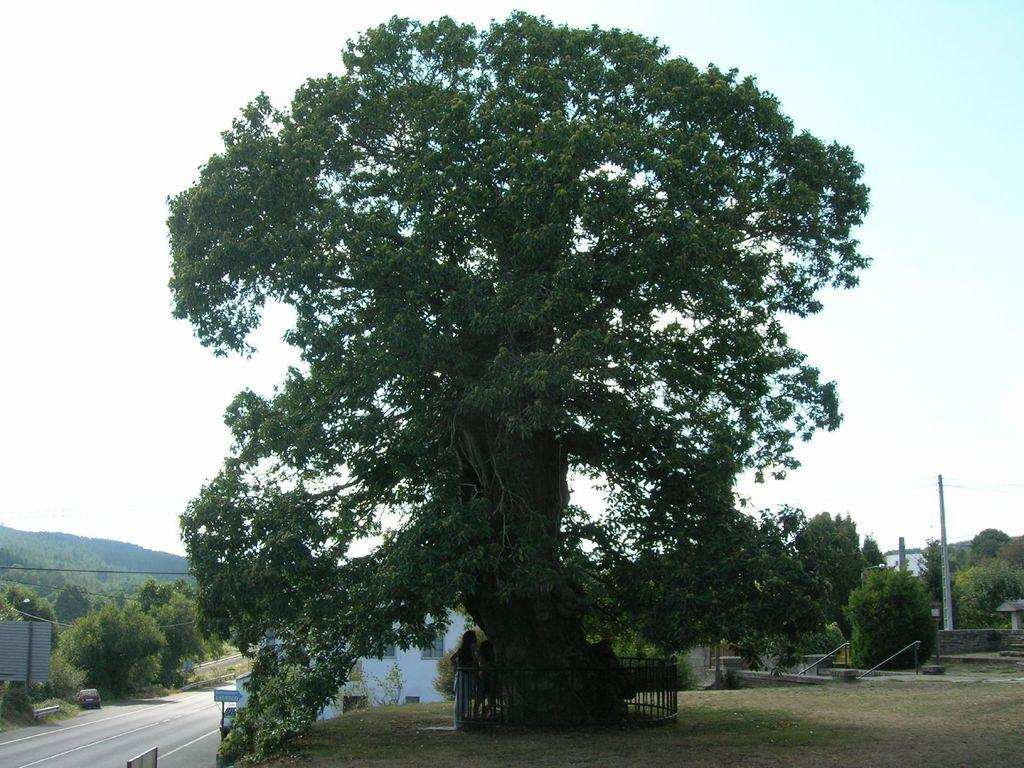What type of vegetation can be seen in the image? There are trees in the image. What color are the trees? The trees are green. What structures are visible in the background of the image? There are buildings in the background of the image. What color are the buildings? The buildings are white. What other objects can be seen in the image? There are poles in the image. What is the color of the sky in the image? The sky is white in the image. Is there a potato growing on one of the trees in the image? There is no potato present in the image. What type of cover is protecting the trees from the rain in the image? There is no mention of rain or any cover in the image; the trees are simply green and visible. 